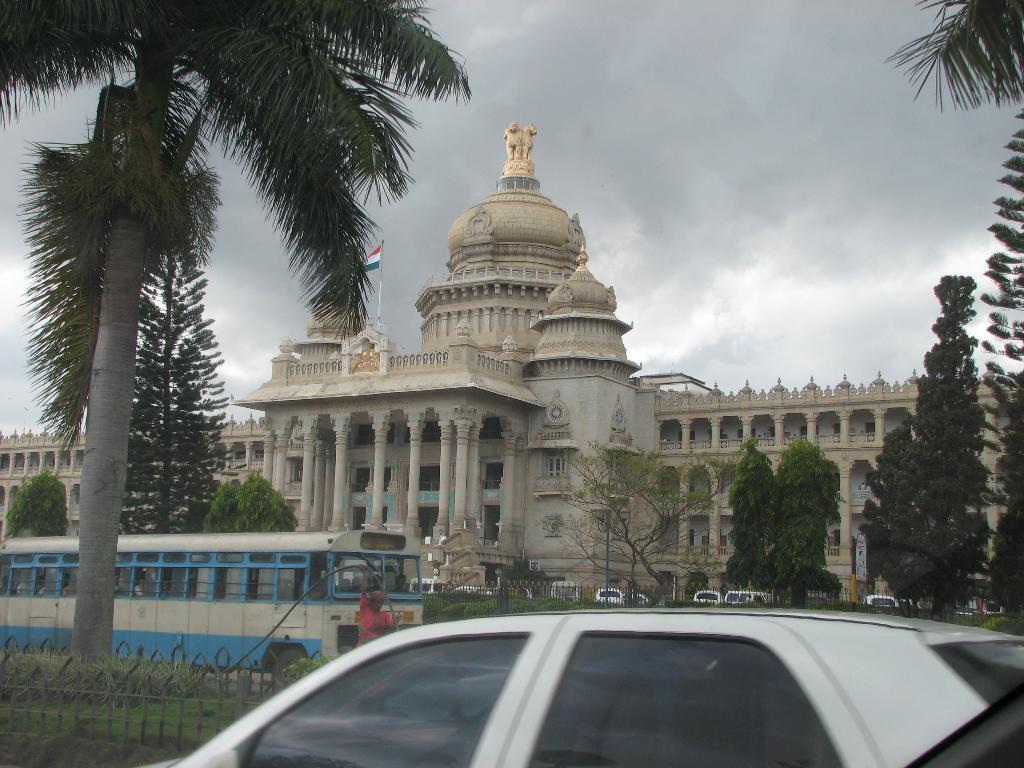What type of structure is visible in the image? There is a building in the image. What else can be seen in the image besides the building? There are vehicles, trees, windows, a fence, pillars, a flag, and a statue visible in the image. What is the condition of the sky in the image? The sky is visible in the background of the image, and there are clouds in the sky. Where can the sheep be found in the image? There are no sheep present in the image. What type of ticket is required to enter the camp in the image? There is no camp or ticket present in the image. 